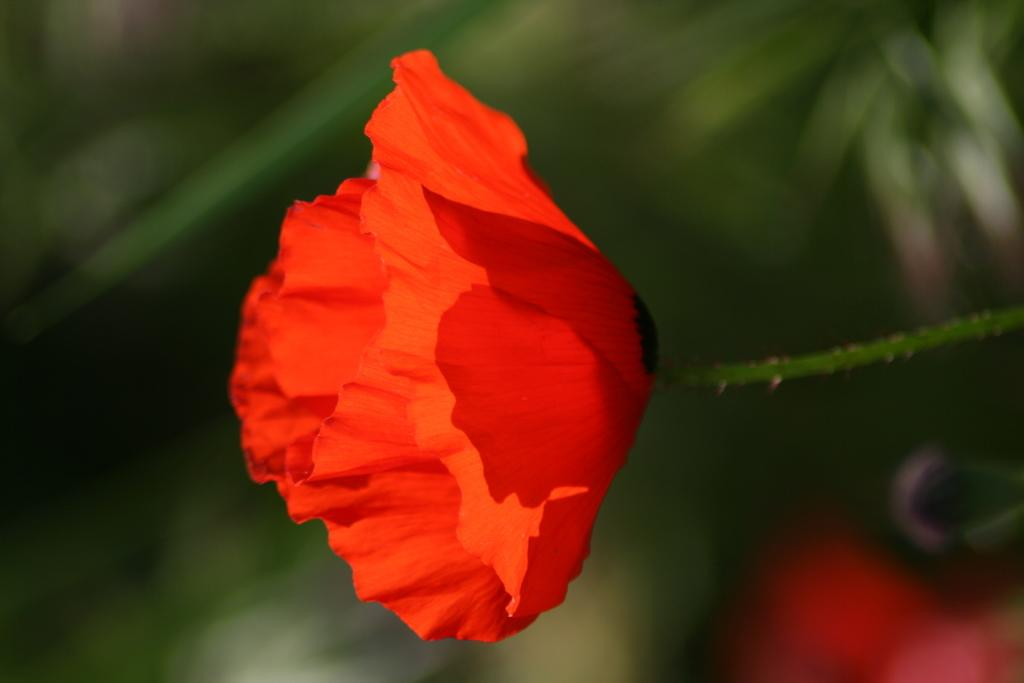What type of flower is in the image? There is a red flower in the image. Can you describe the background of the image? The background of the image is blurred. What type of plastic is used to make the guitar in the image? There is no guitar present in the image; it only features a red flower and a blurred background. 